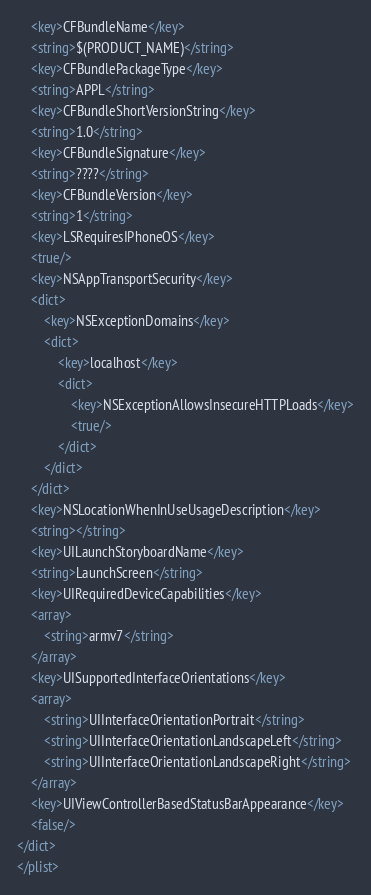Convert code to text. <code><loc_0><loc_0><loc_500><loc_500><_XML_>	<key>CFBundleName</key>
	<string>$(PRODUCT_NAME)</string>
	<key>CFBundlePackageType</key>
	<string>APPL</string>
	<key>CFBundleShortVersionString</key>
	<string>1.0</string>
	<key>CFBundleSignature</key>
	<string>????</string>
	<key>CFBundleVersion</key>
	<string>1</string>
	<key>LSRequiresIPhoneOS</key>
	<true/>
	<key>NSAppTransportSecurity</key>
	<dict>
		<key>NSExceptionDomains</key>
		<dict>
			<key>localhost</key>
			<dict>
				<key>NSExceptionAllowsInsecureHTTPLoads</key>
				<true/>
			</dict>
		</dict>
	</dict>
	<key>NSLocationWhenInUseUsageDescription</key>
	<string></string>
	<key>UILaunchStoryboardName</key>
	<string>LaunchScreen</string>
	<key>UIRequiredDeviceCapabilities</key>
	<array>
		<string>armv7</string>
	</array>
	<key>UISupportedInterfaceOrientations</key>
	<array>
		<string>UIInterfaceOrientationPortrait</string>
		<string>UIInterfaceOrientationLandscapeLeft</string>
		<string>UIInterfaceOrientationLandscapeRight</string>
	</array>
	<key>UIViewControllerBasedStatusBarAppearance</key>
	<false/>
</dict>
</plist>
</code> 